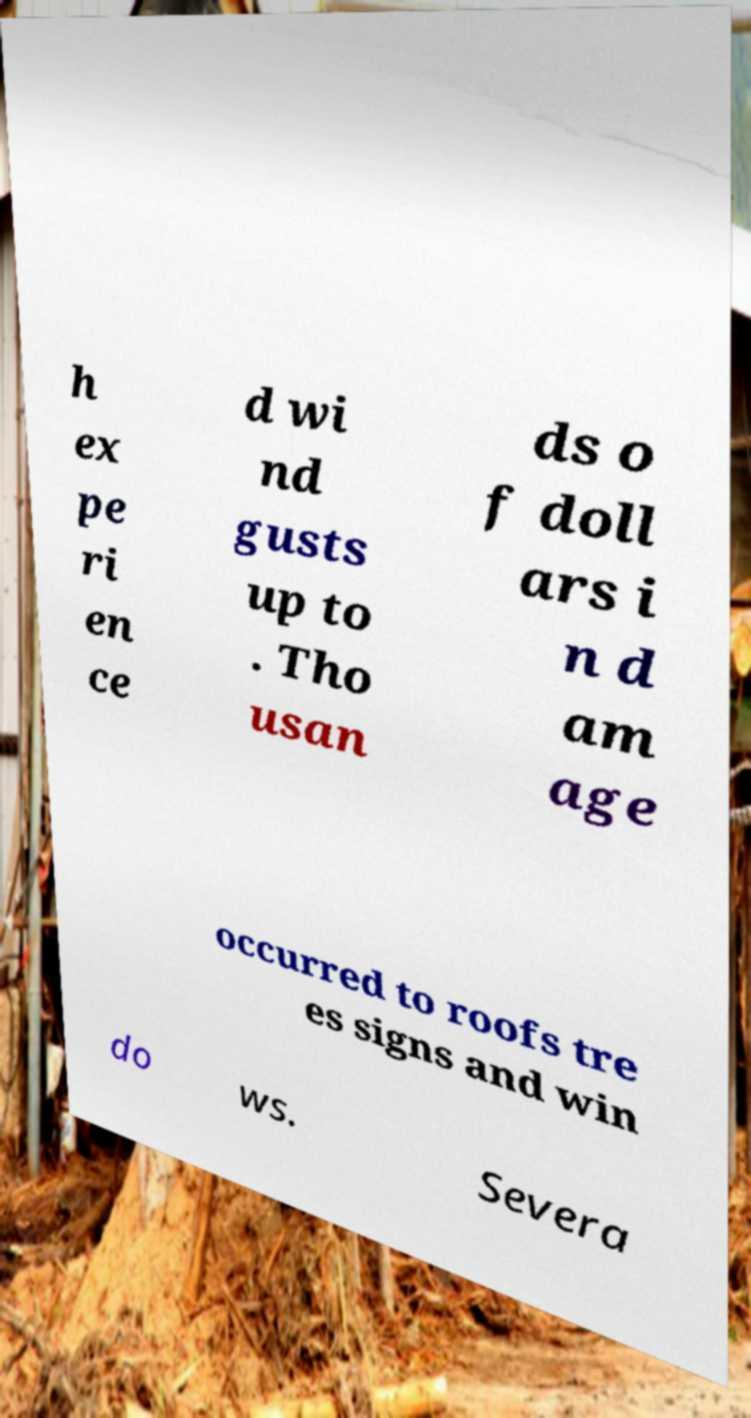Could you extract and type out the text from this image? h ex pe ri en ce d wi nd gusts up to . Tho usan ds o f doll ars i n d am age occurred to roofs tre es signs and win do ws. Severa 